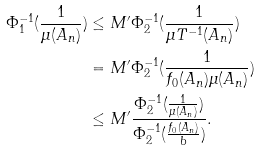Convert formula to latex. <formula><loc_0><loc_0><loc_500><loc_500>\Phi _ { 1 } ^ { - 1 } ( \frac { 1 } { \mu ( A _ { n } ) } ) & \leq M ^ { \prime } \Phi _ { 2 } ^ { - 1 } ( \frac { 1 } { \mu T ^ { - 1 } ( A _ { n } ) } ) \\ & = M ^ { \prime } \Phi _ { 2 } ^ { - 1 } ( \frac { 1 } { f _ { 0 } ( A _ { n } ) \mu ( A _ { n } ) } ) \\ & \leq M ^ { \prime } \frac { \Phi _ { 2 } ^ { - 1 } ( \frac { 1 } { \mu ( A _ { n } ) } ) } { \Phi _ { 2 } ^ { - 1 } ( \frac { f _ { 0 } ( A _ { n } ) } { b } ) } .</formula> 